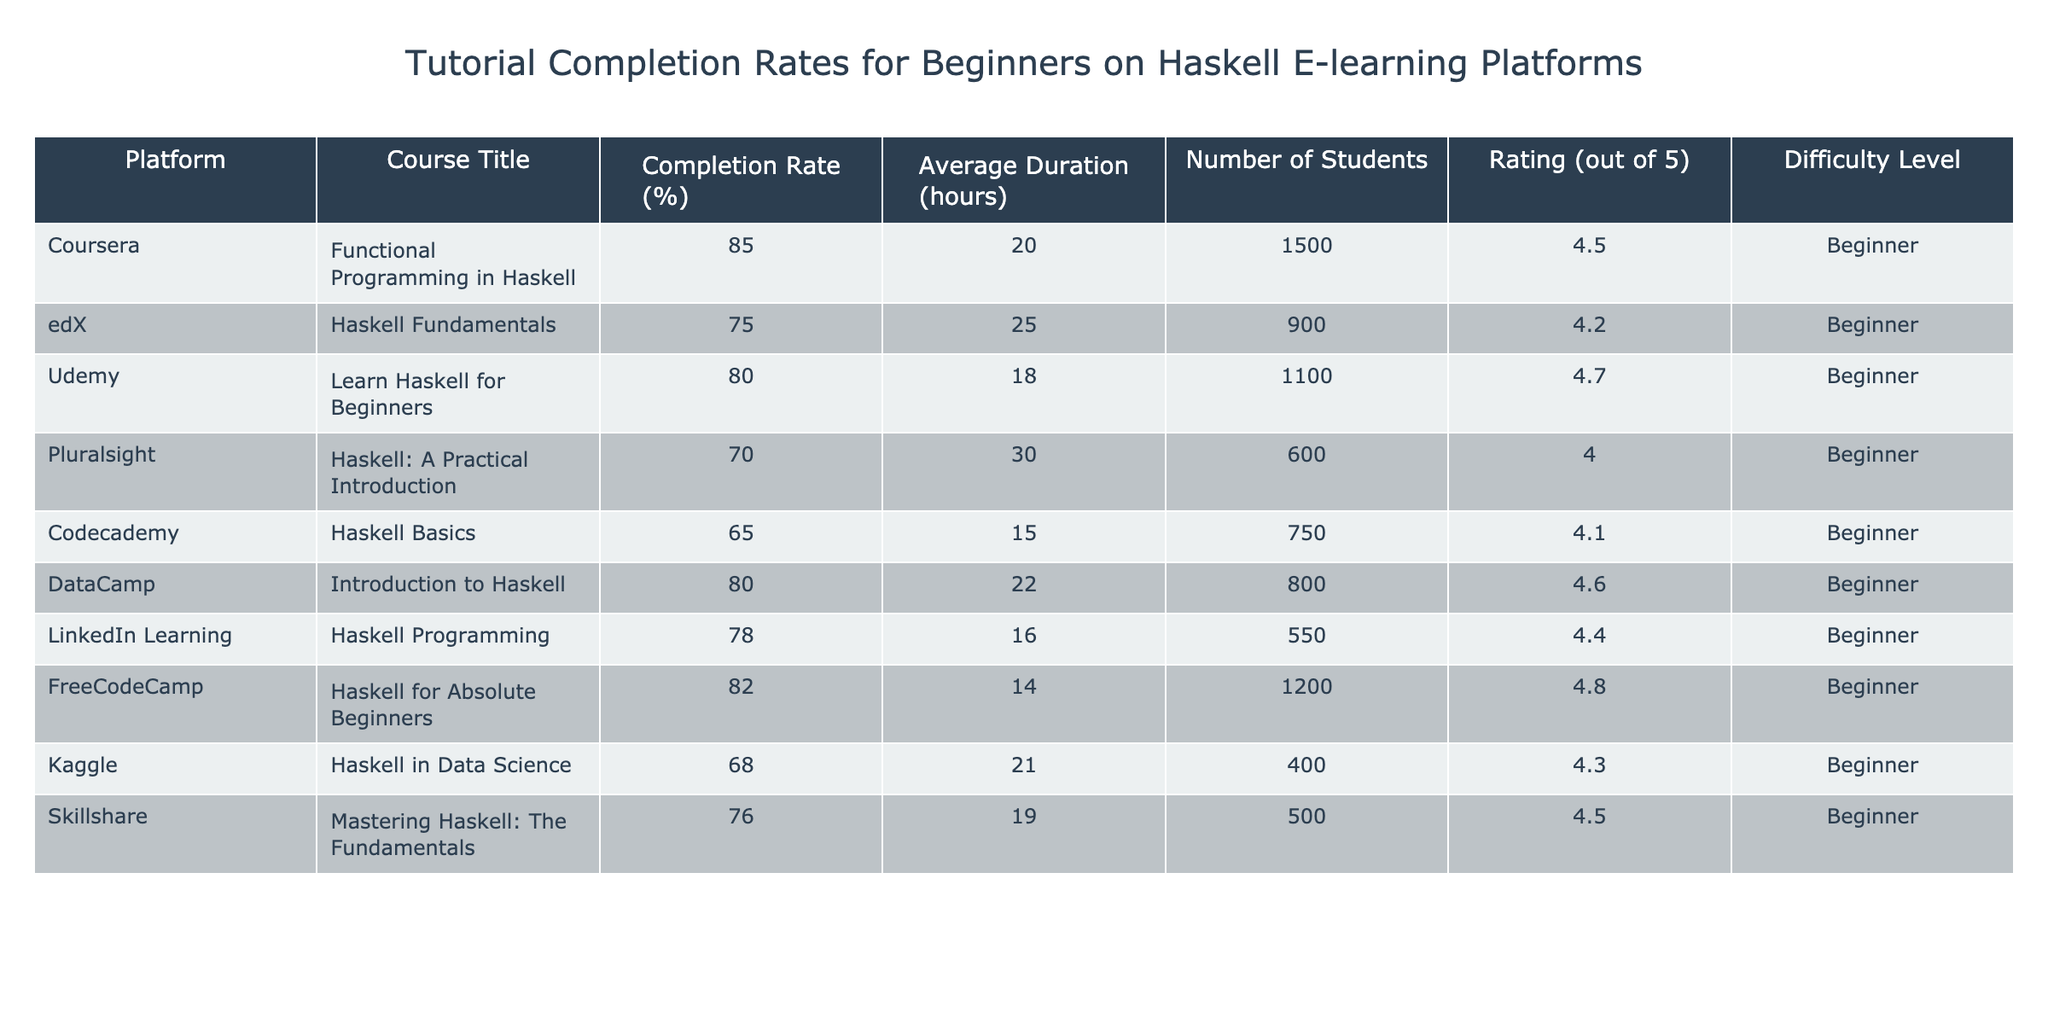What is the highest completion rate among the courses listed? The table shows completion rates for each course. The highest value in the "Completion Rate (%)" column is 85%, which corresponds to the course "Functional Programming in Haskell" on Coursera.
Answer: 85% Which course has the longest average duration? The "Average Duration (hours)" column indicates the time required for each course. The longest duration is 30 hours for the course "Haskell: A Practical Introduction" on Pluralsight.
Answer: Haskell: A Practical Introduction How many students enrolled in the "Haskell Fundamentals" course? The "Number of Students" column shows that the course "Haskell Fundamentals" on edX has 900 students enrolled.
Answer: 900 What is the average completion rate of all the courses listed? To find the average, we sum the completion rates of all courses: 85 + 75 + 80 + 70 + 65 + 80 + 78 + 82 + 68 + 76 =  786, and divide by the number of courses (10). Thus, the average completion rate is 786 / 10 = 78.6%.
Answer: 78.6% Which platform has the highest rating for its beginner Haskell course? Looking at the "Rating (out of 5)" column, the highest rating is 4.8 from the course "Haskell for Absolute Beginners" on FreeCodeCamp.
Answer: FreeCodeCamp Is the completion rate for "Learn Haskell for Beginners" higher than 78%? The completion rate for "Learn Haskell for Beginners" from Udemy is 80%, which is indeed higher than 78%.
Answer: Yes What is the difference in completion rates between the highest and lowest rated courses? The highest rated course is "Haskell for Absolute Beginners" with a completion rate of 82%, while the lowest is "Haskell Basics" with 65%. The difference is 82 - 65 = 17%.
Answer: 17% Which course has both a high completion rate and a low average duration? The course "Haskell for Absolute Beginners" has a completion rate of 82% and an average duration of 14 hours, making it high in completion rate and low in average duration compared to others in the table.
Answer: Haskell for Absolute Beginners How many total students enrolled across all courses? The total number of students is obtained by summing the "Number of Students" for each course: 1500 + 900 + 1100 + 600 + 750 + 800 + 550 + 1200 + 400 + 500 = 6000.
Answer: 6000 Is the course "Introduction to Haskell" rated higher than "Haskell Basics"? The "Introduction to Haskell" course has a rating of 4.6, while "Haskell Basics" has a rating of 4.1. Hence, "Introduction to Haskell" is rated higher.
Answer: Yes 